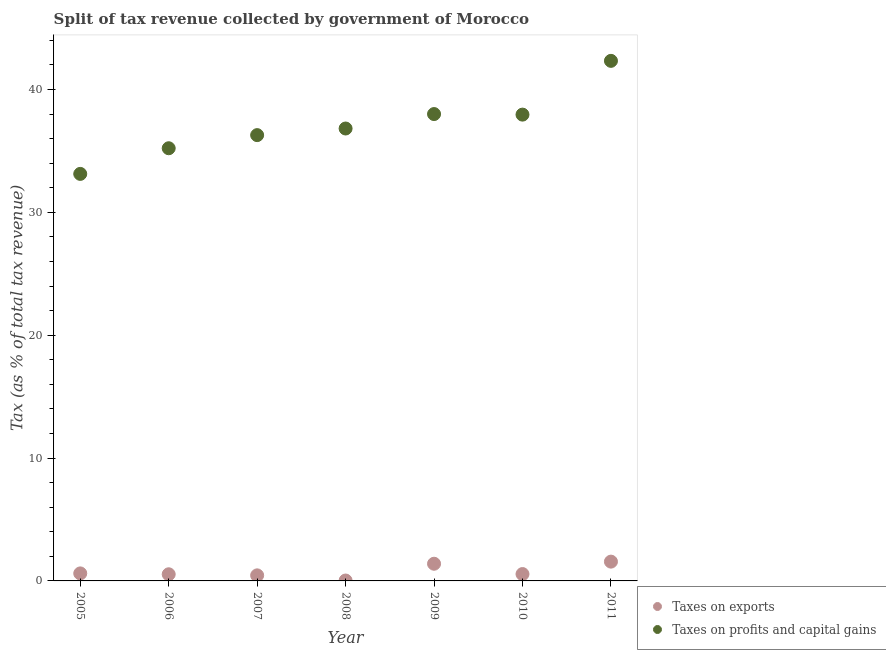What is the percentage of revenue obtained from taxes on exports in 2005?
Give a very brief answer. 0.61. Across all years, what is the maximum percentage of revenue obtained from taxes on exports?
Provide a succinct answer. 1.57. Across all years, what is the minimum percentage of revenue obtained from taxes on profits and capital gains?
Your answer should be very brief. 33.13. In which year was the percentage of revenue obtained from taxes on profits and capital gains maximum?
Your response must be concise. 2011. In which year was the percentage of revenue obtained from taxes on exports minimum?
Ensure brevity in your answer.  2008. What is the total percentage of revenue obtained from taxes on exports in the graph?
Offer a terse response. 5.17. What is the difference between the percentage of revenue obtained from taxes on exports in 2007 and that in 2008?
Provide a short and direct response. 0.42. What is the difference between the percentage of revenue obtained from taxes on profits and capital gains in 2011 and the percentage of revenue obtained from taxes on exports in 2010?
Ensure brevity in your answer.  41.77. What is the average percentage of revenue obtained from taxes on exports per year?
Offer a very short reply. 0.74. In the year 2011, what is the difference between the percentage of revenue obtained from taxes on profits and capital gains and percentage of revenue obtained from taxes on exports?
Provide a short and direct response. 40.76. What is the ratio of the percentage of revenue obtained from taxes on exports in 2005 to that in 2011?
Your response must be concise. 0.39. Is the percentage of revenue obtained from taxes on profits and capital gains in 2008 less than that in 2011?
Your response must be concise. Yes. Is the difference between the percentage of revenue obtained from taxes on exports in 2009 and 2011 greater than the difference between the percentage of revenue obtained from taxes on profits and capital gains in 2009 and 2011?
Offer a very short reply. Yes. What is the difference between the highest and the second highest percentage of revenue obtained from taxes on exports?
Make the answer very short. 0.17. What is the difference between the highest and the lowest percentage of revenue obtained from taxes on profits and capital gains?
Give a very brief answer. 9.2. Is the sum of the percentage of revenue obtained from taxes on exports in 2007 and 2008 greater than the maximum percentage of revenue obtained from taxes on profits and capital gains across all years?
Ensure brevity in your answer.  No. Does the percentage of revenue obtained from taxes on profits and capital gains monotonically increase over the years?
Offer a very short reply. No. Is the percentage of revenue obtained from taxes on profits and capital gains strictly less than the percentage of revenue obtained from taxes on exports over the years?
Ensure brevity in your answer.  No. How many dotlines are there?
Provide a short and direct response. 2. How many years are there in the graph?
Make the answer very short. 7. What is the difference between two consecutive major ticks on the Y-axis?
Keep it short and to the point. 10. Are the values on the major ticks of Y-axis written in scientific E-notation?
Provide a short and direct response. No. How are the legend labels stacked?
Give a very brief answer. Vertical. What is the title of the graph?
Offer a very short reply. Split of tax revenue collected by government of Morocco. What is the label or title of the X-axis?
Make the answer very short. Year. What is the label or title of the Y-axis?
Offer a very short reply. Tax (as % of total tax revenue). What is the Tax (as % of total tax revenue) in Taxes on exports in 2005?
Ensure brevity in your answer.  0.61. What is the Tax (as % of total tax revenue) in Taxes on profits and capital gains in 2005?
Provide a succinct answer. 33.13. What is the Tax (as % of total tax revenue) of Taxes on exports in 2006?
Ensure brevity in your answer.  0.54. What is the Tax (as % of total tax revenue) of Taxes on profits and capital gains in 2006?
Provide a succinct answer. 35.22. What is the Tax (as % of total tax revenue) in Taxes on exports in 2007?
Offer a very short reply. 0.45. What is the Tax (as % of total tax revenue) in Taxes on profits and capital gains in 2007?
Your response must be concise. 36.29. What is the Tax (as % of total tax revenue) of Taxes on exports in 2008?
Provide a short and direct response. 0.03. What is the Tax (as % of total tax revenue) of Taxes on profits and capital gains in 2008?
Offer a terse response. 36.83. What is the Tax (as % of total tax revenue) of Taxes on exports in 2009?
Give a very brief answer. 1.4. What is the Tax (as % of total tax revenue) in Taxes on profits and capital gains in 2009?
Your response must be concise. 38. What is the Tax (as % of total tax revenue) of Taxes on exports in 2010?
Your answer should be very brief. 0.56. What is the Tax (as % of total tax revenue) of Taxes on profits and capital gains in 2010?
Make the answer very short. 37.96. What is the Tax (as % of total tax revenue) of Taxes on exports in 2011?
Offer a very short reply. 1.57. What is the Tax (as % of total tax revenue) in Taxes on profits and capital gains in 2011?
Provide a succinct answer. 42.33. Across all years, what is the maximum Tax (as % of total tax revenue) of Taxes on exports?
Give a very brief answer. 1.57. Across all years, what is the maximum Tax (as % of total tax revenue) in Taxes on profits and capital gains?
Keep it short and to the point. 42.33. Across all years, what is the minimum Tax (as % of total tax revenue) in Taxes on exports?
Provide a short and direct response. 0.03. Across all years, what is the minimum Tax (as % of total tax revenue) of Taxes on profits and capital gains?
Ensure brevity in your answer.  33.13. What is the total Tax (as % of total tax revenue) in Taxes on exports in the graph?
Provide a short and direct response. 5.17. What is the total Tax (as % of total tax revenue) in Taxes on profits and capital gains in the graph?
Provide a short and direct response. 259.75. What is the difference between the Tax (as % of total tax revenue) of Taxes on exports in 2005 and that in 2006?
Provide a succinct answer. 0.07. What is the difference between the Tax (as % of total tax revenue) in Taxes on profits and capital gains in 2005 and that in 2006?
Ensure brevity in your answer.  -2.09. What is the difference between the Tax (as % of total tax revenue) of Taxes on exports in 2005 and that in 2007?
Offer a terse response. 0.16. What is the difference between the Tax (as % of total tax revenue) in Taxes on profits and capital gains in 2005 and that in 2007?
Provide a short and direct response. -3.16. What is the difference between the Tax (as % of total tax revenue) in Taxes on exports in 2005 and that in 2008?
Provide a short and direct response. 0.58. What is the difference between the Tax (as % of total tax revenue) in Taxes on profits and capital gains in 2005 and that in 2008?
Ensure brevity in your answer.  -3.69. What is the difference between the Tax (as % of total tax revenue) of Taxes on exports in 2005 and that in 2009?
Your answer should be compact. -0.79. What is the difference between the Tax (as % of total tax revenue) in Taxes on profits and capital gains in 2005 and that in 2009?
Provide a succinct answer. -4.87. What is the difference between the Tax (as % of total tax revenue) in Taxes on exports in 2005 and that in 2010?
Ensure brevity in your answer.  0.05. What is the difference between the Tax (as % of total tax revenue) in Taxes on profits and capital gains in 2005 and that in 2010?
Your answer should be very brief. -4.82. What is the difference between the Tax (as % of total tax revenue) of Taxes on exports in 2005 and that in 2011?
Provide a succinct answer. -0.96. What is the difference between the Tax (as % of total tax revenue) in Taxes on profits and capital gains in 2005 and that in 2011?
Your response must be concise. -9.2. What is the difference between the Tax (as % of total tax revenue) of Taxes on exports in 2006 and that in 2007?
Make the answer very short. 0.09. What is the difference between the Tax (as % of total tax revenue) of Taxes on profits and capital gains in 2006 and that in 2007?
Ensure brevity in your answer.  -1.07. What is the difference between the Tax (as % of total tax revenue) in Taxes on exports in 2006 and that in 2008?
Keep it short and to the point. 0.51. What is the difference between the Tax (as % of total tax revenue) of Taxes on profits and capital gains in 2006 and that in 2008?
Your answer should be very brief. -1.61. What is the difference between the Tax (as % of total tax revenue) of Taxes on exports in 2006 and that in 2009?
Make the answer very short. -0.86. What is the difference between the Tax (as % of total tax revenue) of Taxes on profits and capital gains in 2006 and that in 2009?
Your response must be concise. -2.78. What is the difference between the Tax (as % of total tax revenue) of Taxes on exports in 2006 and that in 2010?
Give a very brief answer. -0.02. What is the difference between the Tax (as % of total tax revenue) of Taxes on profits and capital gains in 2006 and that in 2010?
Keep it short and to the point. -2.74. What is the difference between the Tax (as % of total tax revenue) in Taxes on exports in 2006 and that in 2011?
Make the answer very short. -1.03. What is the difference between the Tax (as % of total tax revenue) of Taxes on profits and capital gains in 2006 and that in 2011?
Your answer should be compact. -7.11. What is the difference between the Tax (as % of total tax revenue) of Taxes on exports in 2007 and that in 2008?
Give a very brief answer. 0.42. What is the difference between the Tax (as % of total tax revenue) of Taxes on profits and capital gains in 2007 and that in 2008?
Offer a very short reply. -0.54. What is the difference between the Tax (as % of total tax revenue) in Taxes on exports in 2007 and that in 2009?
Your answer should be very brief. -0.95. What is the difference between the Tax (as % of total tax revenue) of Taxes on profits and capital gains in 2007 and that in 2009?
Your answer should be very brief. -1.71. What is the difference between the Tax (as % of total tax revenue) of Taxes on exports in 2007 and that in 2010?
Ensure brevity in your answer.  -0.11. What is the difference between the Tax (as % of total tax revenue) of Taxes on profits and capital gains in 2007 and that in 2010?
Your answer should be very brief. -1.67. What is the difference between the Tax (as % of total tax revenue) of Taxes on exports in 2007 and that in 2011?
Make the answer very short. -1.12. What is the difference between the Tax (as % of total tax revenue) in Taxes on profits and capital gains in 2007 and that in 2011?
Your answer should be very brief. -6.04. What is the difference between the Tax (as % of total tax revenue) in Taxes on exports in 2008 and that in 2009?
Provide a succinct answer. -1.37. What is the difference between the Tax (as % of total tax revenue) in Taxes on profits and capital gains in 2008 and that in 2009?
Make the answer very short. -1.18. What is the difference between the Tax (as % of total tax revenue) in Taxes on exports in 2008 and that in 2010?
Ensure brevity in your answer.  -0.53. What is the difference between the Tax (as % of total tax revenue) in Taxes on profits and capital gains in 2008 and that in 2010?
Offer a very short reply. -1.13. What is the difference between the Tax (as % of total tax revenue) in Taxes on exports in 2008 and that in 2011?
Give a very brief answer. -1.54. What is the difference between the Tax (as % of total tax revenue) of Taxes on profits and capital gains in 2008 and that in 2011?
Your answer should be compact. -5.51. What is the difference between the Tax (as % of total tax revenue) in Taxes on exports in 2009 and that in 2010?
Give a very brief answer. 0.84. What is the difference between the Tax (as % of total tax revenue) in Taxes on profits and capital gains in 2009 and that in 2010?
Provide a succinct answer. 0.05. What is the difference between the Tax (as % of total tax revenue) in Taxes on exports in 2009 and that in 2011?
Your response must be concise. -0.17. What is the difference between the Tax (as % of total tax revenue) of Taxes on profits and capital gains in 2009 and that in 2011?
Offer a terse response. -4.33. What is the difference between the Tax (as % of total tax revenue) in Taxes on exports in 2010 and that in 2011?
Make the answer very short. -1.01. What is the difference between the Tax (as % of total tax revenue) of Taxes on profits and capital gains in 2010 and that in 2011?
Ensure brevity in your answer.  -4.38. What is the difference between the Tax (as % of total tax revenue) of Taxes on exports in 2005 and the Tax (as % of total tax revenue) of Taxes on profits and capital gains in 2006?
Your answer should be very brief. -34.61. What is the difference between the Tax (as % of total tax revenue) of Taxes on exports in 2005 and the Tax (as % of total tax revenue) of Taxes on profits and capital gains in 2007?
Provide a short and direct response. -35.67. What is the difference between the Tax (as % of total tax revenue) in Taxes on exports in 2005 and the Tax (as % of total tax revenue) in Taxes on profits and capital gains in 2008?
Your response must be concise. -36.21. What is the difference between the Tax (as % of total tax revenue) of Taxes on exports in 2005 and the Tax (as % of total tax revenue) of Taxes on profits and capital gains in 2009?
Give a very brief answer. -37.39. What is the difference between the Tax (as % of total tax revenue) of Taxes on exports in 2005 and the Tax (as % of total tax revenue) of Taxes on profits and capital gains in 2010?
Your answer should be compact. -37.34. What is the difference between the Tax (as % of total tax revenue) in Taxes on exports in 2005 and the Tax (as % of total tax revenue) in Taxes on profits and capital gains in 2011?
Offer a terse response. -41.72. What is the difference between the Tax (as % of total tax revenue) of Taxes on exports in 2006 and the Tax (as % of total tax revenue) of Taxes on profits and capital gains in 2007?
Your answer should be very brief. -35.75. What is the difference between the Tax (as % of total tax revenue) in Taxes on exports in 2006 and the Tax (as % of total tax revenue) in Taxes on profits and capital gains in 2008?
Provide a succinct answer. -36.28. What is the difference between the Tax (as % of total tax revenue) of Taxes on exports in 2006 and the Tax (as % of total tax revenue) of Taxes on profits and capital gains in 2009?
Your answer should be compact. -37.46. What is the difference between the Tax (as % of total tax revenue) of Taxes on exports in 2006 and the Tax (as % of total tax revenue) of Taxes on profits and capital gains in 2010?
Your response must be concise. -37.41. What is the difference between the Tax (as % of total tax revenue) of Taxes on exports in 2006 and the Tax (as % of total tax revenue) of Taxes on profits and capital gains in 2011?
Keep it short and to the point. -41.79. What is the difference between the Tax (as % of total tax revenue) of Taxes on exports in 2007 and the Tax (as % of total tax revenue) of Taxes on profits and capital gains in 2008?
Your response must be concise. -36.37. What is the difference between the Tax (as % of total tax revenue) of Taxes on exports in 2007 and the Tax (as % of total tax revenue) of Taxes on profits and capital gains in 2009?
Your answer should be very brief. -37.55. What is the difference between the Tax (as % of total tax revenue) in Taxes on exports in 2007 and the Tax (as % of total tax revenue) in Taxes on profits and capital gains in 2010?
Offer a terse response. -37.5. What is the difference between the Tax (as % of total tax revenue) in Taxes on exports in 2007 and the Tax (as % of total tax revenue) in Taxes on profits and capital gains in 2011?
Your answer should be compact. -41.88. What is the difference between the Tax (as % of total tax revenue) of Taxes on exports in 2008 and the Tax (as % of total tax revenue) of Taxes on profits and capital gains in 2009?
Your response must be concise. -37.97. What is the difference between the Tax (as % of total tax revenue) in Taxes on exports in 2008 and the Tax (as % of total tax revenue) in Taxes on profits and capital gains in 2010?
Offer a terse response. -37.92. What is the difference between the Tax (as % of total tax revenue) of Taxes on exports in 2008 and the Tax (as % of total tax revenue) of Taxes on profits and capital gains in 2011?
Make the answer very short. -42.3. What is the difference between the Tax (as % of total tax revenue) of Taxes on exports in 2009 and the Tax (as % of total tax revenue) of Taxes on profits and capital gains in 2010?
Your response must be concise. -36.56. What is the difference between the Tax (as % of total tax revenue) in Taxes on exports in 2009 and the Tax (as % of total tax revenue) in Taxes on profits and capital gains in 2011?
Offer a very short reply. -40.93. What is the difference between the Tax (as % of total tax revenue) in Taxes on exports in 2010 and the Tax (as % of total tax revenue) in Taxes on profits and capital gains in 2011?
Offer a very short reply. -41.77. What is the average Tax (as % of total tax revenue) in Taxes on exports per year?
Offer a very short reply. 0.74. What is the average Tax (as % of total tax revenue) in Taxes on profits and capital gains per year?
Offer a terse response. 37.11. In the year 2005, what is the difference between the Tax (as % of total tax revenue) in Taxes on exports and Tax (as % of total tax revenue) in Taxes on profits and capital gains?
Give a very brief answer. -32.52. In the year 2006, what is the difference between the Tax (as % of total tax revenue) of Taxes on exports and Tax (as % of total tax revenue) of Taxes on profits and capital gains?
Offer a terse response. -34.68. In the year 2007, what is the difference between the Tax (as % of total tax revenue) in Taxes on exports and Tax (as % of total tax revenue) in Taxes on profits and capital gains?
Provide a succinct answer. -35.83. In the year 2008, what is the difference between the Tax (as % of total tax revenue) in Taxes on exports and Tax (as % of total tax revenue) in Taxes on profits and capital gains?
Make the answer very short. -36.79. In the year 2009, what is the difference between the Tax (as % of total tax revenue) in Taxes on exports and Tax (as % of total tax revenue) in Taxes on profits and capital gains?
Offer a terse response. -36.6. In the year 2010, what is the difference between the Tax (as % of total tax revenue) in Taxes on exports and Tax (as % of total tax revenue) in Taxes on profits and capital gains?
Offer a very short reply. -37.4. In the year 2011, what is the difference between the Tax (as % of total tax revenue) in Taxes on exports and Tax (as % of total tax revenue) in Taxes on profits and capital gains?
Offer a terse response. -40.76. What is the ratio of the Tax (as % of total tax revenue) of Taxes on exports in 2005 to that in 2006?
Your response must be concise. 1.13. What is the ratio of the Tax (as % of total tax revenue) of Taxes on profits and capital gains in 2005 to that in 2006?
Provide a succinct answer. 0.94. What is the ratio of the Tax (as % of total tax revenue) of Taxes on exports in 2005 to that in 2007?
Ensure brevity in your answer.  1.35. What is the ratio of the Tax (as % of total tax revenue) in Taxes on profits and capital gains in 2005 to that in 2007?
Give a very brief answer. 0.91. What is the ratio of the Tax (as % of total tax revenue) of Taxes on exports in 2005 to that in 2008?
Make the answer very short. 18.73. What is the ratio of the Tax (as % of total tax revenue) in Taxes on profits and capital gains in 2005 to that in 2008?
Your answer should be compact. 0.9. What is the ratio of the Tax (as % of total tax revenue) of Taxes on exports in 2005 to that in 2009?
Your answer should be compact. 0.44. What is the ratio of the Tax (as % of total tax revenue) of Taxes on profits and capital gains in 2005 to that in 2009?
Ensure brevity in your answer.  0.87. What is the ratio of the Tax (as % of total tax revenue) in Taxes on exports in 2005 to that in 2010?
Keep it short and to the point. 1.1. What is the ratio of the Tax (as % of total tax revenue) in Taxes on profits and capital gains in 2005 to that in 2010?
Ensure brevity in your answer.  0.87. What is the ratio of the Tax (as % of total tax revenue) in Taxes on exports in 2005 to that in 2011?
Your answer should be compact. 0.39. What is the ratio of the Tax (as % of total tax revenue) of Taxes on profits and capital gains in 2005 to that in 2011?
Offer a very short reply. 0.78. What is the ratio of the Tax (as % of total tax revenue) in Taxes on exports in 2006 to that in 2007?
Make the answer very short. 1.19. What is the ratio of the Tax (as % of total tax revenue) in Taxes on profits and capital gains in 2006 to that in 2007?
Your response must be concise. 0.97. What is the ratio of the Tax (as % of total tax revenue) of Taxes on exports in 2006 to that in 2008?
Offer a very short reply. 16.55. What is the ratio of the Tax (as % of total tax revenue) of Taxes on profits and capital gains in 2006 to that in 2008?
Offer a very short reply. 0.96. What is the ratio of the Tax (as % of total tax revenue) of Taxes on exports in 2006 to that in 2009?
Provide a succinct answer. 0.39. What is the ratio of the Tax (as % of total tax revenue) in Taxes on profits and capital gains in 2006 to that in 2009?
Make the answer very short. 0.93. What is the ratio of the Tax (as % of total tax revenue) in Taxes on exports in 2006 to that in 2010?
Give a very brief answer. 0.97. What is the ratio of the Tax (as % of total tax revenue) in Taxes on profits and capital gains in 2006 to that in 2010?
Ensure brevity in your answer.  0.93. What is the ratio of the Tax (as % of total tax revenue) of Taxes on exports in 2006 to that in 2011?
Provide a succinct answer. 0.34. What is the ratio of the Tax (as % of total tax revenue) of Taxes on profits and capital gains in 2006 to that in 2011?
Provide a short and direct response. 0.83. What is the ratio of the Tax (as % of total tax revenue) in Taxes on exports in 2007 to that in 2008?
Give a very brief answer. 13.86. What is the ratio of the Tax (as % of total tax revenue) in Taxes on profits and capital gains in 2007 to that in 2008?
Provide a short and direct response. 0.99. What is the ratio of the Tax (as % of total tax revenue) of Taxes on exports in 2007 to that in 2009?
Provide a succinct answer. 0.32. What is the ratio of the Tax (as % of total tax revenue) of Taxes on profits and capital gains in 2007 to that in 2009?
Your response must be concise. 0.95. What is the ratio of the Tax (as % of total tax revenue) in Taxes on exports in 2007 to that in 2010?
Your answer should be compact. 0.81. What is the ratio of the Tax (as % of total tax revenue) in Taxes on profits and capital gains in 2007 to that in 2010?
Offer a terse response. 0.96. What is the ratio of the Tax (as % of total tax revenue) in Taxes on exports in 2007 to that in 2011?
Ensure brevity in your answer.  0.29. What is the ratio of the Tax (as % of total tax revenue) in Taxes on profits and capital gains in 2007 to that in 2011?
Give a very brief answer. 0.86. What is the ratio of the Tax (as % of total tax revenue) of Taxes on exports in 2008 to that in 2009?
Give a very brief answer. 0.02. What is the ratio of the Tax (as % of total tax revenue) of Taxes on exports in 2008 to that in 2010?
Ensure brevity in your answer.  0.06. What is the ratio of the Tax (as % of total tax revenue) in Taxes on profits and capital gains in 2008 to that in 2010?
Your answer should be compact. 0.97. What is the ratio of the Tax (as % of total tax revenue) in Taxes on exports in 2008 to that in 2011?
Offer a terse response. 0.02. What is the ratio of the Tax (as % of total tax revenue) of Taxes on profits and capital gains in 2008 to that in 2011?
Give a very brief answer. 0.87. What is the ratio of the Tax (as % of total tax revenue) in Taxes on exports in 2009 to that in 2010?
Provide a succinct answer. 2.5. What is the ratio of the Tax (as % of total tax revenue) of Taxes on profits and capital gains in 2009 to that in 2010?
Your answer should be very brief. 1. What is the ratio of the Tax (as % of total tax revenue) of Taxes on exports in 2009 to that in 2011?
Your answer should be very brief. 0.89. What is the ratio of the Tax (as % of total tax revenue) in Taxes on profits and capital gains in 2009 to that in 2011?
Offer a terse response. 0.9. What is the ratio of the Tax (as % of total tax revenue) in Taxes on exports in 2010 to that in 2011?
Offer a terse response. 0.36. What is the ratio of the Tax (as % of total tax revenue) of Taxes on profits and capital gains in 2010 to that in 2011?
Provide a short and direct response. 0.9. What is the difference between the highest and the second highest Tax (as % of total tax revenue) of Taxes on exports?
Your answer should be compact. 0.17. What is the difference between the highest and the second highest Tax (as % of total tax revenue) in Taxes on profits and capital gains?
Your answer should be compact. 4.33. What is the difference between the highest and the lowest Tax (as % of total tax revenue) in Taxes on exports?
Provide a short and direct response. 1.54. What is the difference between the highest and the lowest Tax (as % of total tax revenue) of Taxes on profits and capital gains?
Your response must be concise. 9.2. 